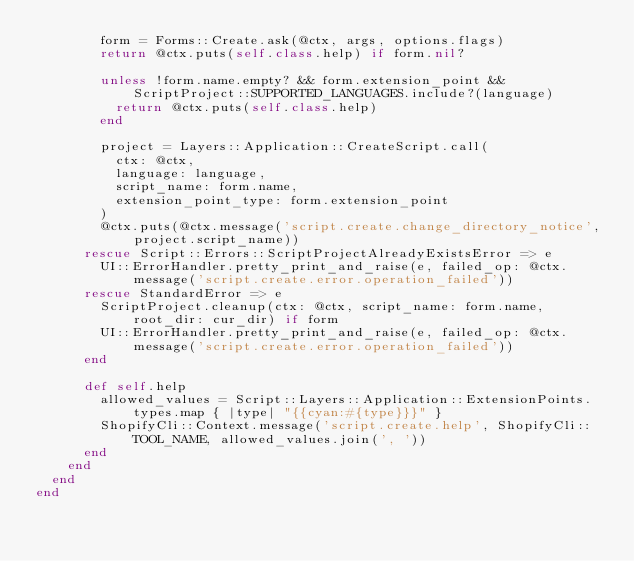<code> <loc_0><loc_0><loc_500><loc_500><_Ruby_>        form = Forms::Create.ask(@ctx, args, options.flags)
        return @ctx.puts(self.class.help) if form.nil?

        unless !form.name.empty? && form.extension_point && ScriptProject::SUPPORTED_LANGUAGES.include?(language)
          return @ctx.puts(self.class.help)
        end

        project = Layers::Application::CreateScript.call(
          ctx: @ctx,
          language: language,
          script_name: form.name,
          extension_point_type: form.extension_point
        )
        @ctx.puts(@ctx.message('script.create.change_directory_notice', project.script_name))
      rescue Script::Errors::ScriptProjectAlreadyExistsError => e
        UI::ErrorHandler.pretty_print_and_raise(e, failed_op: @ctx.message('script.create.error.operation_failed'))
      rescue StandardError => e
        ScriptProject.cleanup(ctx: @ctx, script_name: form.name, root_dir: cur_dir) if form
        UI::ErrorHandler.pretty_print_and_raise(e, failed_op: @ctx.message('script.create.error.operation_failed'))
      end

      def self.help
        allowed_values = Script::Layers::Application::ExtensionPoints.types.map { |type| "{{cyan:#{type}}}" }
        ShopifyCli::Context.message('script.create.help', ShopifyCli::TOOL_NAME, allowed_values.join(', '))
      end
    end
  end
end
</code> 